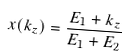Convert formula to latex. <formula><loc_0><loc_0><loc_500><loc_500>x ( k _ { z } ) = \frac { E _ { 1 } + k _ { z } } { E _ { 1 } + E _ { 2 } }</formula> 